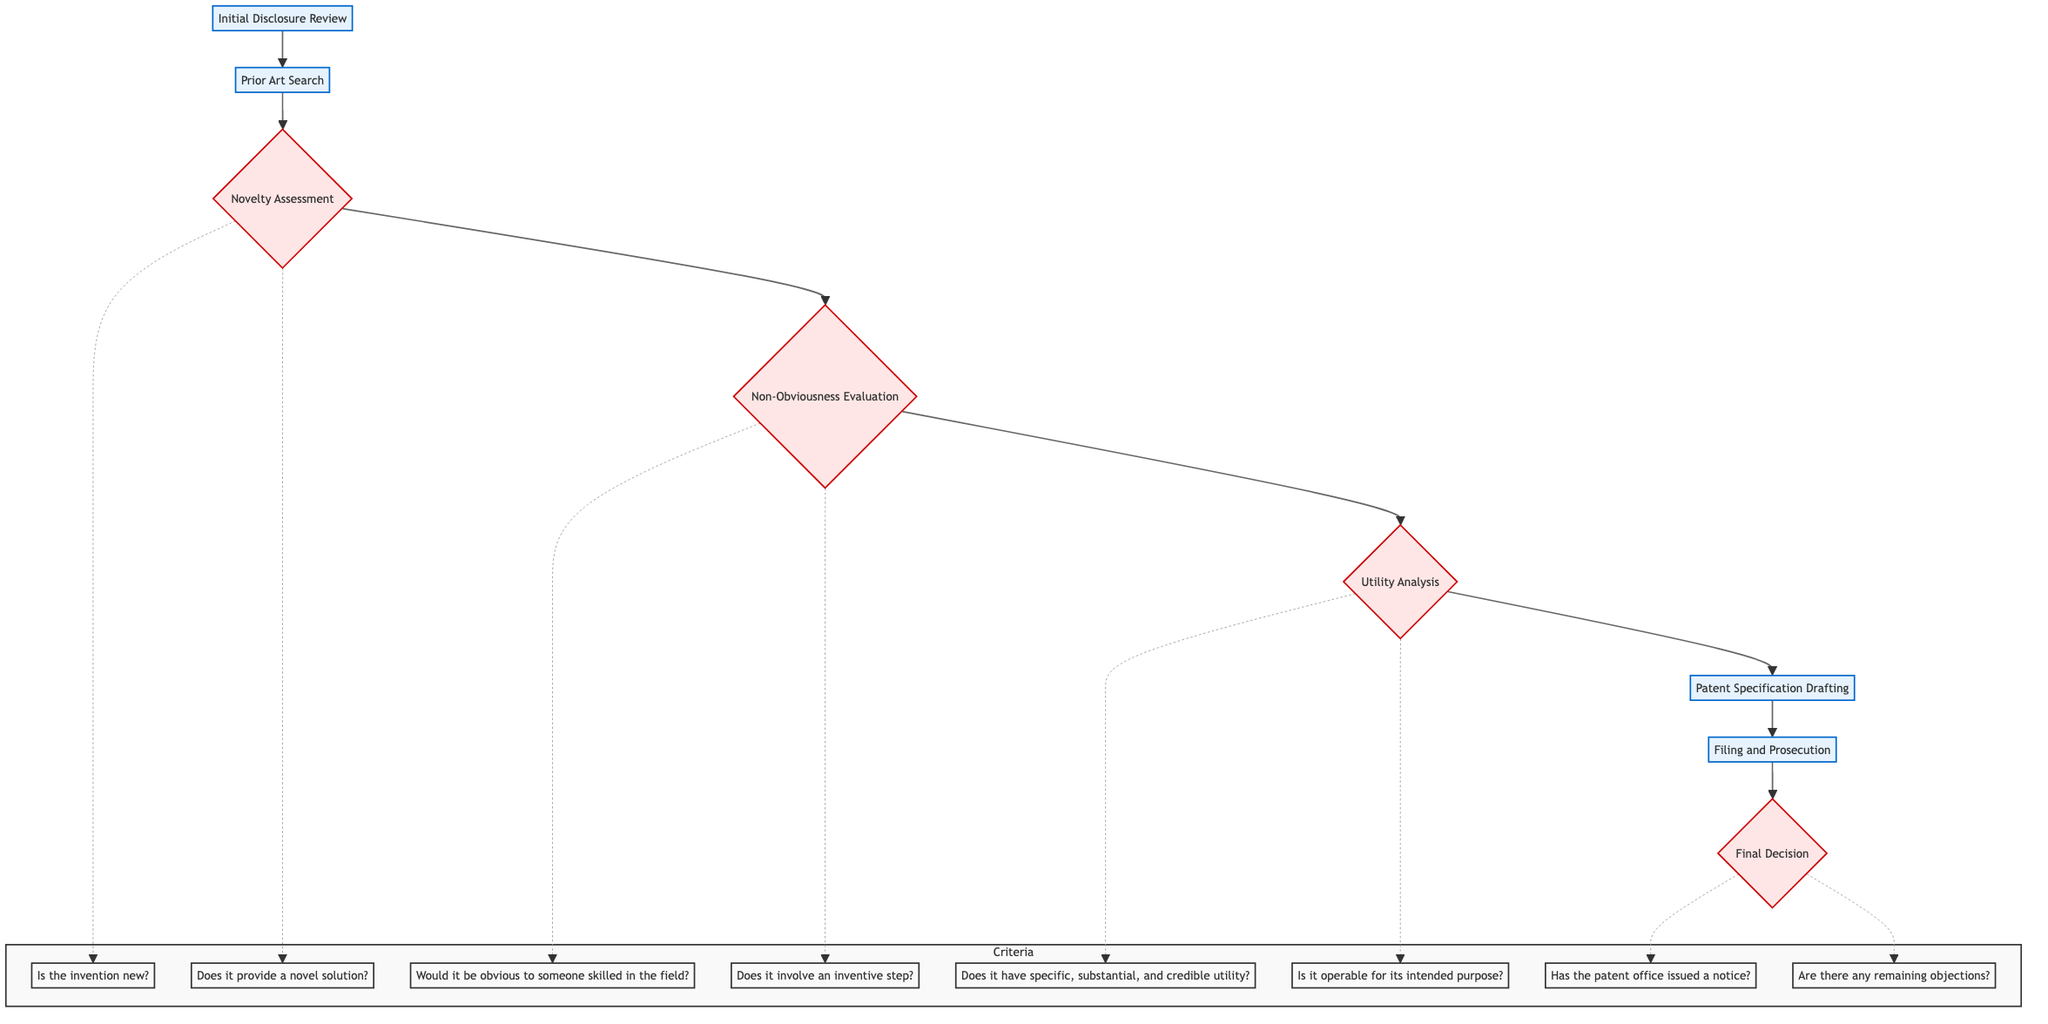What is the first step in the flowchart? The first step is labeled as "Initial Disclosure Review," indicating it is the starting point of the evaluation process for patentability.
Answer: Initial Disclosure Review How many decision points are in the flowchart? The flowchart includes four decision points, indicated by the curly brackets surrounding the "Novelty Assessment," "Non-Obviousness Evaluation," "Utility Analysis," and "Final Decision."
Answer: 4 What is the last step before the final decision? The last step before reaching the final decision is "Filing and Prosecution," which involves managing the process with the patent office.
Answer: Filing and Prosecution What are the criteria associated with the novelty assessment? The novelty assessment includes two criteria: "Is the invention new?" and "Does it provide a novel solution not disclosed in prior art?" which help determine if the invention meets novelty requirements.
Answer: Is the invention new?, Does it provide a novel solution? Which step directly follows the prior art search? The step that directly follows "Prior Art Search" is "Novelty Assessment," indicating the progression in the evaluation process after searching for existing patents and publications.
Answer: Novelty Assessment What is the significance of the arrow directions in this flowchart? The arrows pointing upwards indicate a progression of steps from the initial review to the final decision, highlighting the sequential nature of the patentability evaluation process.
Answer: Progression of steps 